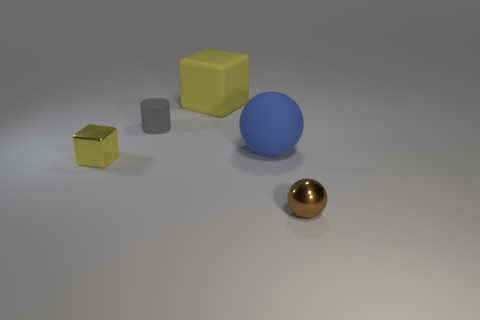There is a large blue matte object; how many blocks are in front of it? In the image, there are a total of three blocks positioned in front of the large blue matte sphere, each varying in color and size. 